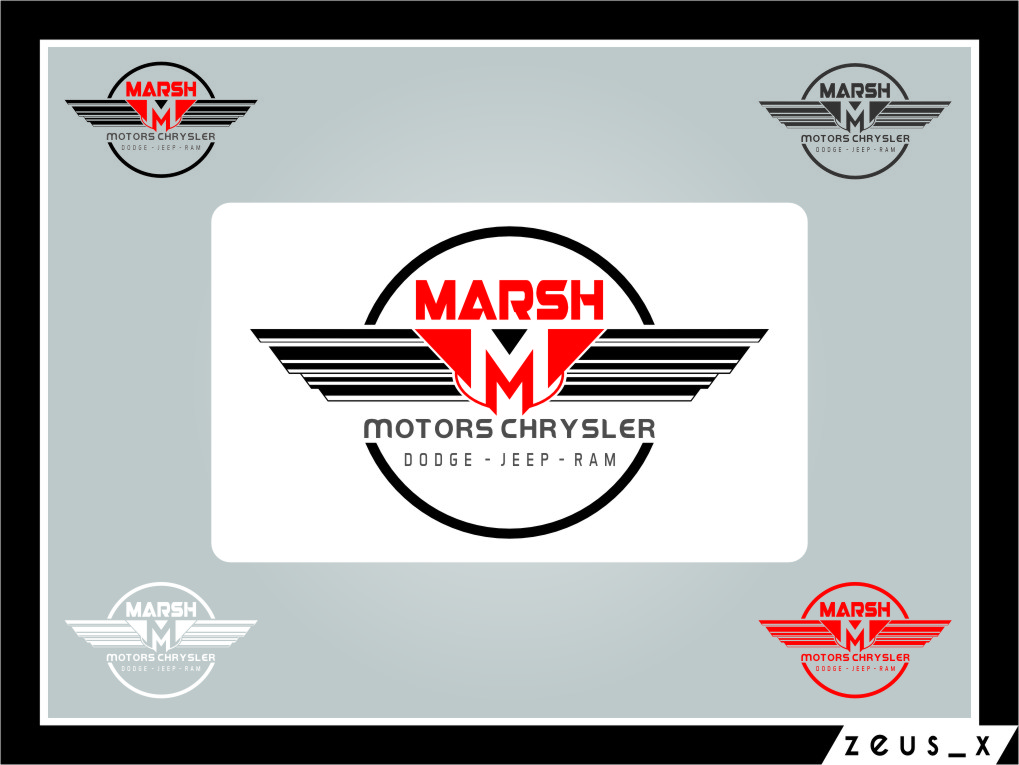What does the inclusion of multiple car brand names within the logo imply about the company? The inclusion of multiple car brand names like 'CHRYSLER DODGE - JEEP - RAM' within the logo implies that the company represented by the logo likely deals with a diverse range of vehicles and possibly provides a variety of automotive services. It suggests a dealership or conglomerate that offers sales, service, and perhaps even customization for these specific brands, showcasing their expertise and authorized affiliation with multiple respected manufacturers in the automotive industry. Could it also suggest any potential business strategies or market positions? Absolutely, featuring multiple renowned automotive brands within a single logo could be indicative of a strategic positioning aimed at capturing a larger segment of the market. By associating with multiple brands, the company can appeal to diverse customer preferences and needs. This strategic diversity allows for cross-promotion opportunities and strengthens its market presence by offering more choices and attracting a wider audience interested in different types of vehicles, from luxury sedans to rugged SUVs. 